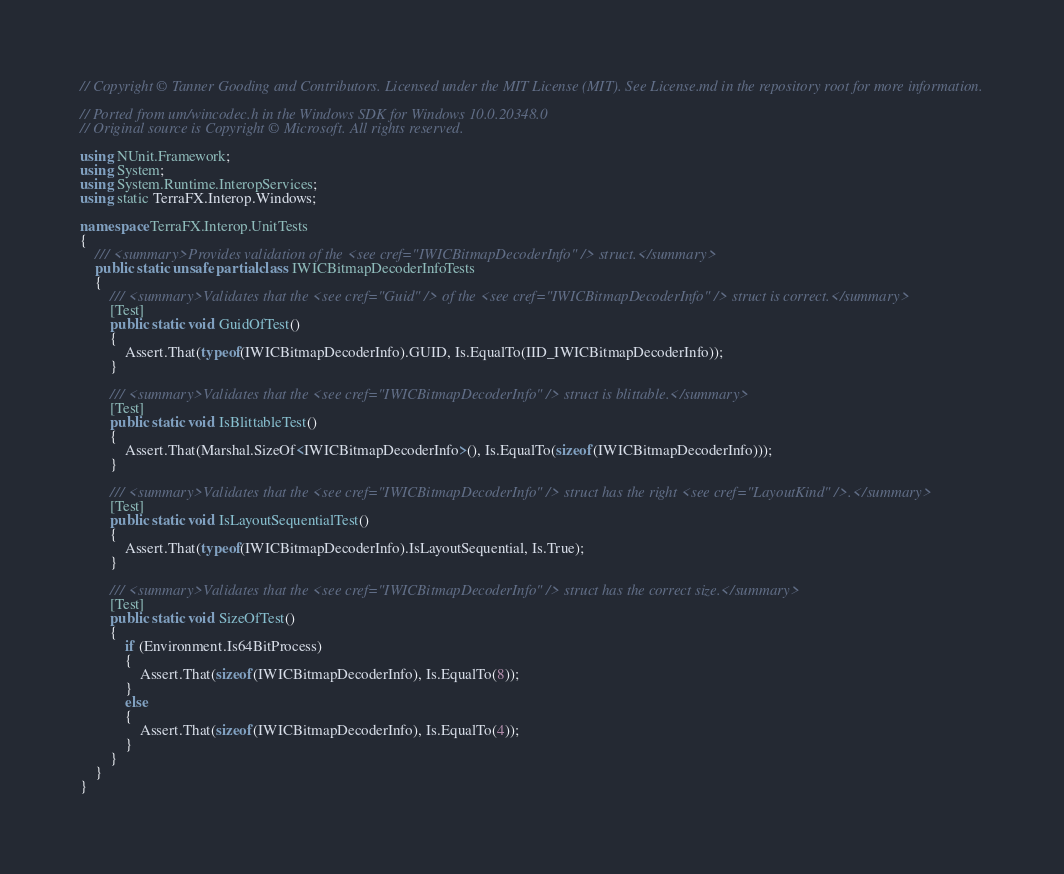<code> <loc_0><loc_0><loc_500><loc_500><_C#_>// Copyright © Tanner Gooding and Contributors. Licensed under the MIT License (MIT). See License.md in the repository root for more information.

// Ported from um/wincodec.h in the Windows SDK for Windows 10.0.20348.0
// Original source is Copyright © Microsoft. All rights reserved.

using NUnit.Framework;
using System;
using System.Runtime.InteropServices;
using static TerraFX.Interop.Windows;

namespace TerraFX.Interop.UnitTests
{
    /// <summary>Provides validation of the <see cref="IWICBitmapDecoderInfo" /> struct.</summary>
    public static unsafe partial class IWICBitmapDecoderInfoTests
    {
        /// <summary>Validates that the <see cref="Guid" /> of the <see cref="IWICBitmapDecoderInfo" /> struct is correct.</summary>
        [Test]
        public static void GuidOfTest()
        {
            Assert.That(typeof(IWICBitmapDecoderInfo).GUID, Is.EqualTo(IID_IWICBitmapDecoderInfo));
        }

        /// <summary>Validates that the <see cref="IWICBitmapDecoderInfo" /> struct is blittable.</summary>
        [Test]
        public static void IsBlittableTest()
        {
            Assert.That(Marshal.SizeOf<IWICBitmapDecoderInfo>(), Is.EqualTo(sizeof(IWICBitmapDecoderInfo)));
        }

        /// <summary>Validates that the <see cref="IWICBitmapDecoderInfo" /> struct has the right <see cref="LayoutKind" />.</summary>
        [Test]
        public static void IsLayoutSequentialTest()
        {
            Assert.That(typeof(IWICBitmapDecoderInfo).IsLayoutSequential, Is.True);
        }

        /// <summary>Validates that the <see cref="IWICBitmapDecoderInfo" /> struct has the correct size.</summary>
        [Test]
        public static void SizeOfTest()
        {
            if (Environment.Is64BitProcess)
            {
                Assert.That(sizeof(IWICBitmapDecoderInfo), Is.EqualTo(8));
            }
            else
            {
                Assert.That(sizeof(IWICBitmapDecoderInfo), Is.EqualTo(4));
            }
        }
    }
}
</code> 